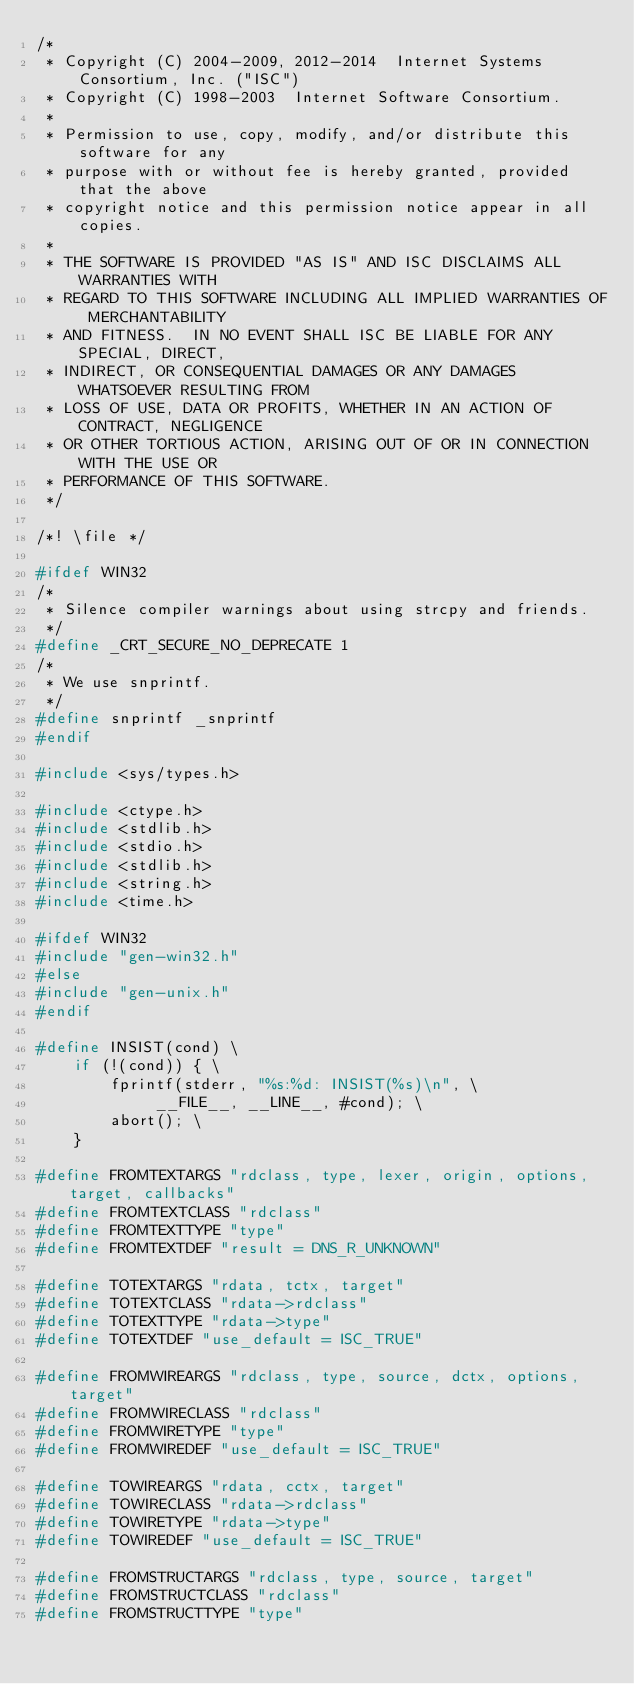Convert code to text. <code><loc_0><loc_0><loc_500><loc_500><_C_>/*
 * Copyright (C) 2004-2009, 2012-2014  Internet Systems Consortium, Inc. ("ISC")
 * Copyright (C) 1998-2003  Internet Software Consortium.
 *
 * Permission to use, copy, modify, and/or distribute this software for any
 * purpose with or without fee is hereby granted, provided that the above
 * copyright notice and this permission notice appear in all copies.
 *
 * THE SOFTWARE IS PROVIDED "AS IS" AND ISC DISCLAIMS ALL WARRANTIES WITH
 * REGARD TO THIS SOFTWARE INCLUDING ALL IMPLIED WARRANTIES OF MERCHANTABILITY
 * AND FITNESS.  IN NO EVENT SHALL ISC BE LIABLE FOR ANY SPECIAL, DIRECT,
 * INDIRECT, OR CONSEQUENTIAL DAMAGES OR ANY DAMAGES WHATSOEVER RESULTING FROM
 * LOSS OF USE, DATA OR PROFITS, WHETHER IN AN ACTION OF CONTRACT, NEGLIGENCE
 * OR OTHER TORTIOUS ACTION, ARISING OUT OF OR IN CONNECTION WITH THE USE OR
 * PERFORMANCE OF THIS SOFTWARE.
 */

/*! \file */

#ifdef WIN32
/*
 * Silence compiler warnings about using strcpy and friends.
 */
#define _CRT_SECURE_NO_DEPRECATE 1
/*
 * We use snprintf.
 */
#define snprintf _snprintf
#endif

#include <sys/types.h>

#include <ctype.h>
#include <stdlib.h>
#include <stdio.h>
#include <stdlib.h>
#include <string.h>
#include <time.h>

#ifdef WIN32
#include "gen-win32.h"
#else
#include "gen-unix.h"
#endif

#define INSIST(cond) \
	if (!(cond)) { \
		fprintf(stderr, "%s:%d: INSIST(%s)\n", \
			 __FILE__, __LINE__, #cond); \
		abort(); \
	}

#define FROMTEXTARGS "rdclass, type, lexer, origin, options, target, callbacks"
#define FROMTEXTCLASS "rdclass"
#define FROMTEXTTYPE "type"
#define FROMTEXTDEF "result = DNS_R_UNKNOWN"

#define TOTEXTARGS "rdata, tctx, target"
#define TOTEXTCLASS "rdata->rdclass"
#define TOTEXTTYPE "rdata->type"
#define TOTEXTDEF "use_default = ISC_TRUE"

#define FROMWIREARGS "rdclass, type, source, dctx, options, target"
#define FROMWIRECLASS "rdclass"
#define FROMWIRETYPE "type"
#define FROMWIREDEF "use_default = ISC_TRUE"

#define TOWIREARGS "rdata, cctx, target"
#define TOWIRECLASS "rdata->rdclass"
#define TOWIRETYPE "rdata->type"
#define TOWIREDEF "use_default = ISC_TRUE"

#define FROMSTRUCTARGS "rdclass, type, source, target"
#define FROMSTRUCTCLASS "rdclass"
#define FROMSTRUCTTYPE "type"</code> 